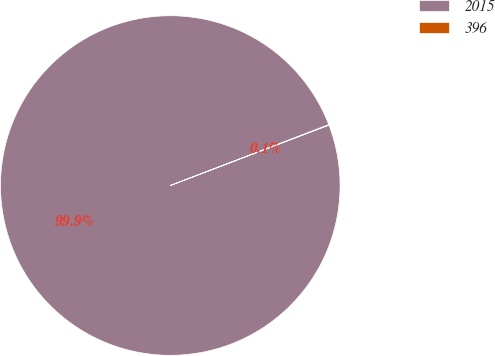Convert chart to OTSL. <chart><loc_0><loc_0><loc_500><loc_500><pie_chart><fcel>2015<fcel>396<nl><fcel>99.95%<fcel>0.05%<nl></chart> 